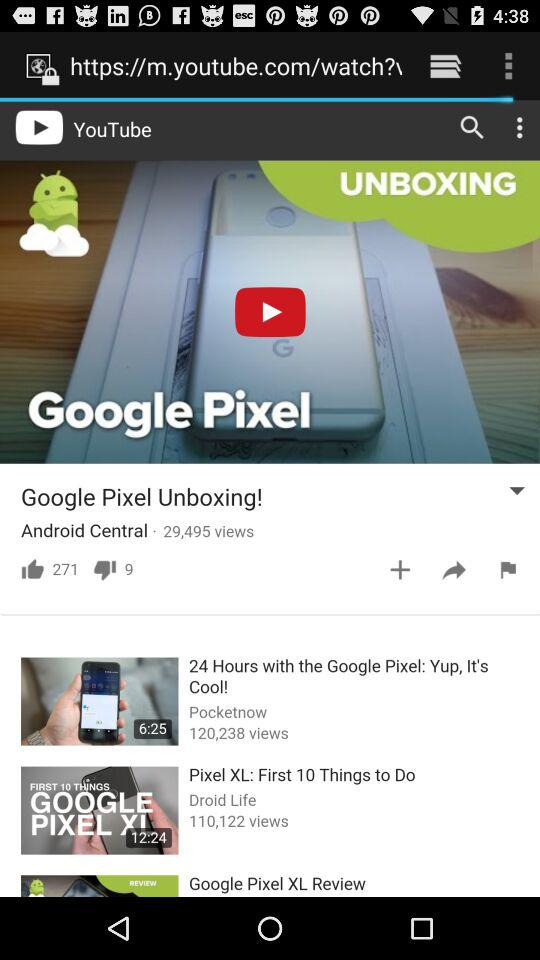How many views are there on "Google Pixel Unboxing!"? There are 29,495 views. 